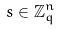<formula> <loc_0><loc_0><loc_500><loc_500>s \in \mathbb { Z } _ { q } ^ { n }</formula> 